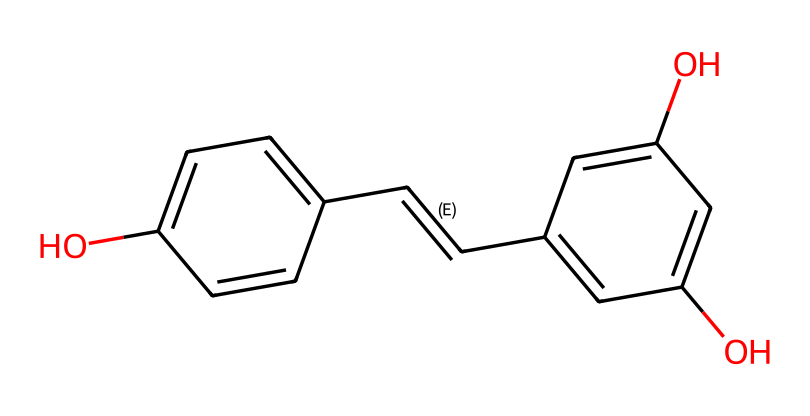What is the name of this compound? The chemical structure corresponds to resveratrol, a well-known polyphenolic compound found in red wine. This conclusion is drawn from the common knowledge of the compound's structure and its presence in literature.
Answer: resveratrol How many aromatic rings are present in the structure? The structure has two distinct aromatic rings, identified by the six-membered carbon rings with alternating double bonds. Counting the distinct rings confirms this feature of the molecule.
Answer: two What are the functional groups present in this compound? The structure contains two hydroxyl (-OH) groups, indicating the presence of phenolic functional groups. This is observed by looking for the -OH directly attached to the aromatic rings in the chemical representation.
Answer: hydroxyl groups What is the total number of carbon atoms in this structure? By analyzing the SMILES representation, you can count each carbon atom present, which totals to 14 carbon atoms in the entire molecule. This is done by visually following the carbon (C) symbols in the structure.
Answer: fourteen Is this compound a monomer or a dimer? Resveratrol is considered a monomer as it consists of a single unit of its structure; it does not bond with another identical unit to form a dimer. This can be determined by assessing the basic atomic structure and noting there are no repeating units.
Answer: monomer Which part of the molecule contributes to its antioxidant properties? The presence of the hydroxyl groups (-OH) on the aromatic rings is crucial for its antioxidant properties. These groups are known to donate electrons, which traps free radicals and inhibits oxidative stress. This conclusion is based on the functional roles of phenolic compounds.
Answer: hydroxyl groups 